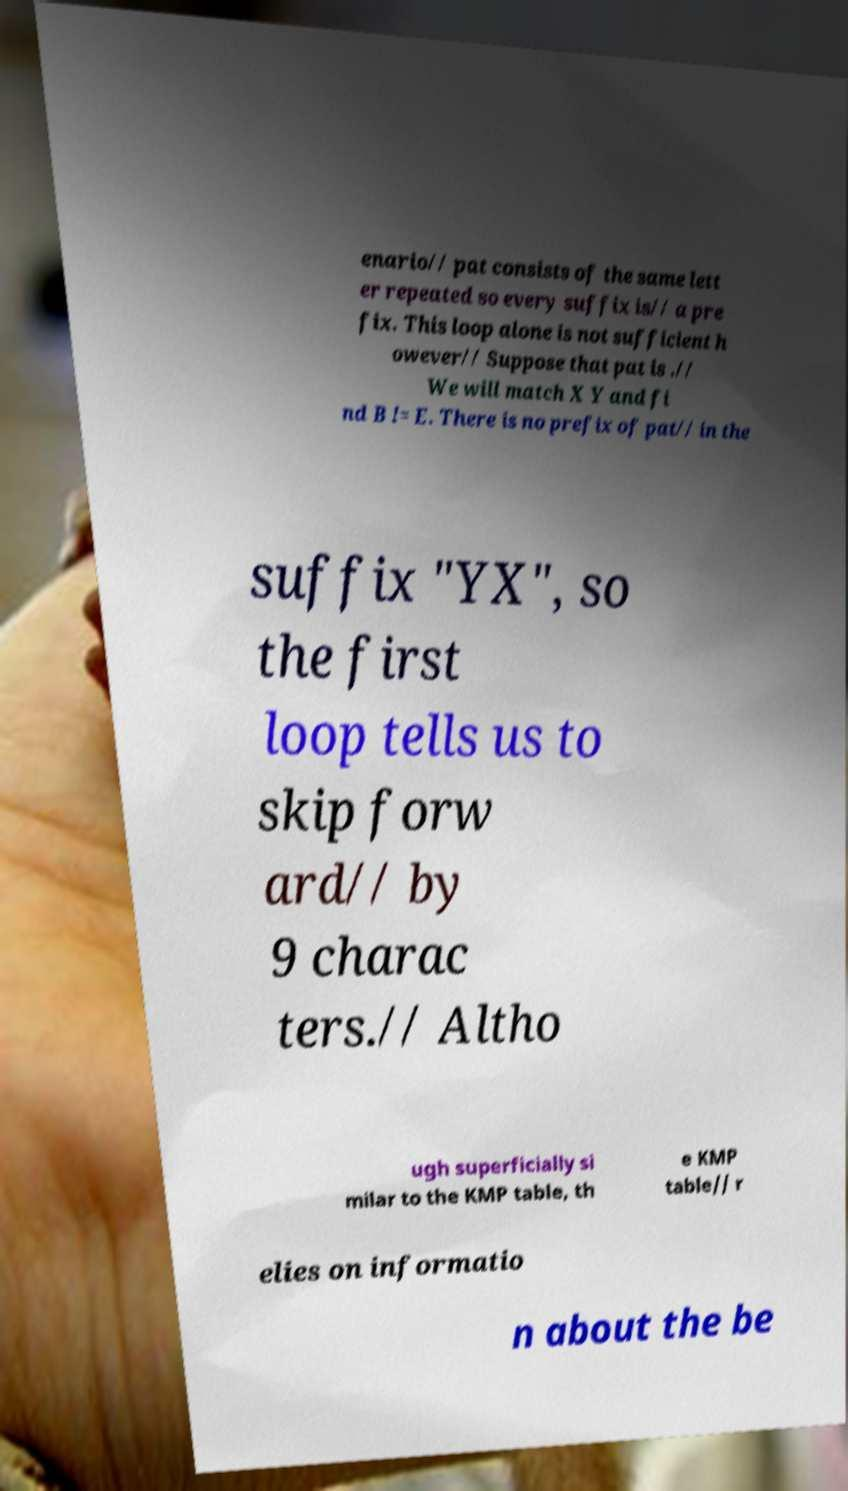Could you extract and type out the text from this image? enario// pat consists of the same lett er repeated so every suffix is// a pre fix. This loop alone is not sufficient h owever// Suppose that pat is .// We will match X Y and fi nd B != E. There is no prefix of pat// in the suffix "YX", so the first loop tells us to skip forw ard// by 9 charac ters.// Altho ugh superficially si milar to the KMP table, th e KMP table// r elies on informatio n about the be 